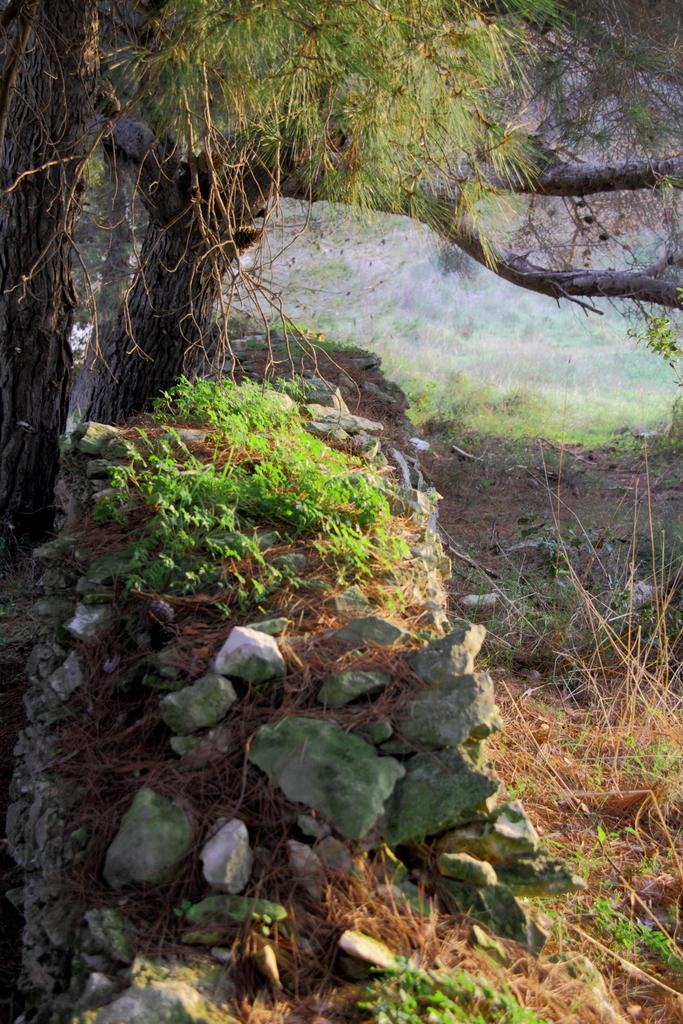What is the main feature of the landscape in the image? There is an open grass ground in the image. Are there any objects or features on the grass ground? Yes, there are stones on the grass ground. What can be seen on the left side of the image? There are trees on the left side of the image. Can you tell me how many friends are sitting on the grass ground with the grandfather in the image? There is no grandfather or friends present in the image; it only features an open grass ground, stones, and trees. 